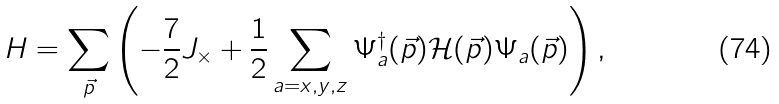<formula> <loc_0><loc_0><loc_500><loc_500>H = \sum _ { \vec { p } } \left ( - \frac { 7 } { 2 } J _ { \times } + \frac { 1 } { 2 } \sum _ { a = x , y , z } \Psi ^ { \dagger } _ { a } ( \vec { p } ) \mathcal { H } ( \vec { p } ) \Psi _ { a } ( \vec { p } ) \right ) ,</formula> 